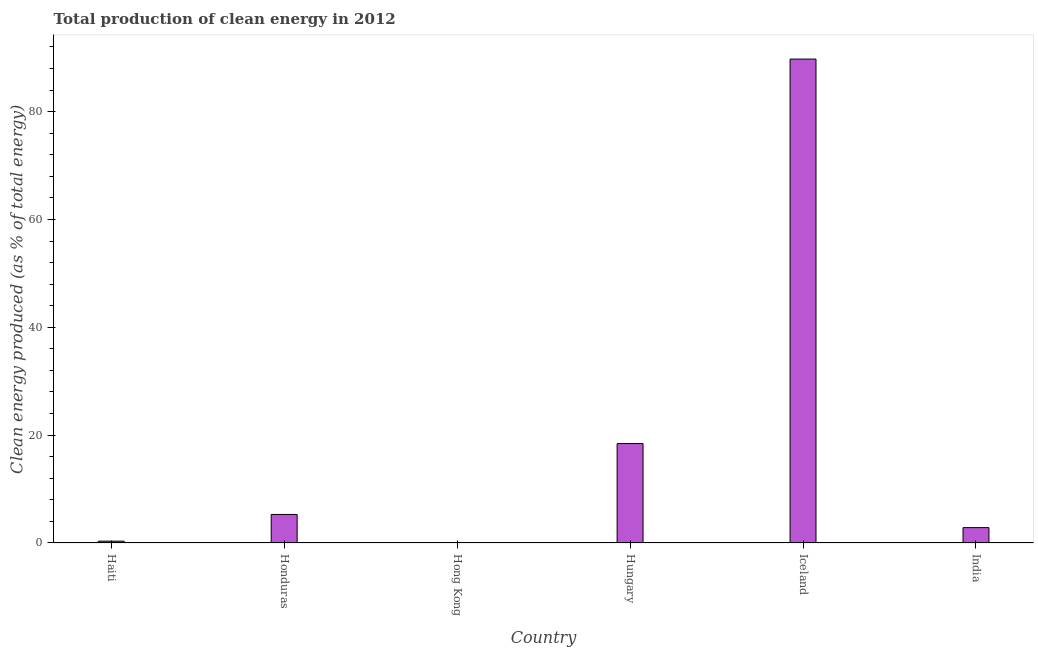Does the graph contain grids?
Ensure brevity in your answer.  No. What is the title of the graph?
Offer a very short reply. Total production of clean energy in 2012. What is the label or title of the Y-axis?
Your response must be concise. Clean energy produced (as % of total energy). What is the production of clean energy in Hong Kong?
Your response must be concise. 0. Across all countries, what is the maximum production of clean energy?
Give a very brief answer. 89.74. Across all countries, what is the minimum production of clean energy?
Your answer should be very brief. 0. In which country was the production of clean energy maximum?
Make the answer very short. Iceland. In which country was the production of clean energy minimum?
Keep it short and to the point. Hong Kong. What is the sum of the production of clean energy?
Your answer should be very brief. 116.66. What is the difference between the production of clean energy in Honduras and Hong Kong?
Make the answer very short. 5.29. What is the average production of clean energy per country?
Provide a short and direct response. 19.44. What is the median production of clean energy?
Provide a short and direct response. 4.07. What is the ratio of the production of clean energy in Honduras to that in India?
Give a very brief answer. 1.86. Is the difference between the production of clean energy in Hungary and India greater than the difference between any two countries?
Make the answer very short. No. What is the difference between the highest and the second highest production of clean energy?
Your answer should be very brief. 71.3. Is the sum of the production of clean energy in Haiti and India greater than the maximum production of clean energy across all countries?
Your answer should be compact. No. What is the difference between the highest and the lowest production of clean energy?
Provide a short and direct response. 89.74. In how many countries, is the production of clean energy greater than the average production of clean energy taken over all countries?
Give a very brief answer. 1. How many bars are there?
Offer a terse response. 6. Are all the bars in the graph horizontal?
Your response must be concise. No. Are the values on the major ticks of Y-axis written in scientific E-notation?
Your answer should be very brief. No. What is the Clean energy produced (as % of total energy) of Haiti?
Keep it short and to the point. 0.34. What is the Clean energy produced (as % of total energy) of Honduras?
Offer a very short reply. 5.29. What is the Clean energy produced (as % of total energy) of Hong Kong?
Your response must be concise. 0. What is the Clean energy produced (as % of total energy) of Hungary?
Your answer should be compact. 18.44. What is the Clean energy produced (as % of total energy) in Iceland?
Your answer should be compact. 89.74. What is the Clean energy produced (as % of total energy) in India?
Your answer should be compact. 2.85. What is the difference between the Clean energy produced (as % of total energy) in Haiti and Honduras?
Offer a terse response. -4.96. What is the difference between the Clean energy produced (as % of total energy) in Haiti and Hong Kong?
Offer a very short reply. 0.34. What is the difference between the Clean energy produced (as % of total energy) in Haiti and Hungary?
Your answer should be compact. -18.1. What is the difference between the Clean energy produced (as % of total energy) in Haiti and Iceland?
Ensure brevity in your answer.  -89.4. What is the difference between the Clean energy produced (as % of total energy) in Haiti and India?
Make the answer very short. -2.51. What is the difference between the Clean energy produced (as % of total energy) in Honduras and Hong Kong?
Offer a very short reply. 5.29. What is the difference between the Clean energy produced (as % of total energy) in Honduras and Hungary?
Provide a short and direct response. -13.14. What is the difference between the Clean energy produced (as % of total energy) in Honduras and Iceland?
Ensure brevity in your answer.  -84.44. What is the difference between the Clean energy produced (as % of total energy) in Honduras and India?
Offer a very short reply. 2.44. What is the difference between the Clean energy produced (as % of total energy) in Hong Kong and Hungary?
Provide a succinct answer. -18.43. What is the difference between the Clean energy produced (as % of total energy) in Hong Kong and Iceland?
Your response must be concise. -89.74. What is the difference between the Clean energy produced (as % of total energy) in Hong Kong and India?
Make the answer very short. -2.85. What is the difference between the Clean energy produced (as % of total energy) in Hungary and Iceland?
Make the answer very short. -71.3. What is the difference between the Clean energy produced (as % of total energy) in Hungary and India?
Keep it short and to the point. 15.59. What is the difference between the Clean energy produced (as % of total energy) in Iceland and India?
Provide a short and direct response. 86.89. What is the ratio of the Clean energy produced (as % of total energy) in Haiti to that in Honduras?
Make the answer very short. 0.06. What is the ratio of the Clean energy produced (as % of total energy) in Haiti to that in Hong Kong?
Provide a succinct answer. 287.54. What is the ratio of the Clean energy produced (as % of total energy) in Haiti to that in Hungary?
Your answer should be compact. 0.02. What is the ratio of the Clean energy produced (as % of total energy) in Haiti to that in Iceland?
Ensure brevity in your answer.  0. What is the ratio of the Clean energy produced (as % of total energy) in Haiti to that in India?
Offer a very short reply. 0.12. What is the ratio of the Clean energy produced (as % of total energy) in Honduras to that in Hong Kong?
Offer a terse response. 4504.03. What is the ratio of the Clean energy produced (as % of total energy) in Honduras to that in Hungary?
Make the answer very short. 0.29. What is the ratio of the Clean energy produced (as % of total energy) in Honduras to that in Iceland?
Provide a short and direct response. 0.06. What is the ratio of the Clean energy produced (as % of total energy) in Honduras to that in India?
Keep it short and to the point. 1.86. What is the ratio of the Clean energy produced (as % of total energy) in Hong Kong to that in Hungary?
Make the answer very short. 0. What is the ratio of the Clean energy produced (as % of total energy) in Hong Kong to that in Iceland?
Ensure brevity in your answer.  0. What is the ratio of the Clean energy produced (as % of total energy) in Hungary to that in Iceland?
Provide a short and direct response. 0.2. What is the ratio of the Clean energy produced (as % of total energy) in Hungary to that in India?
Your answer should be compact. 6.47. What is the ratio of the Clean energy produced (as % of total energy) in Iceland to that in India?
Offer a very short reply. 31.48. 